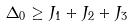<formula> <loc_0><loc_0><loc_500><loc_500>\Delta _ { 0 } \geq J _ { 1 } + J _ { 2 } + J _ { 3 }</formula> 